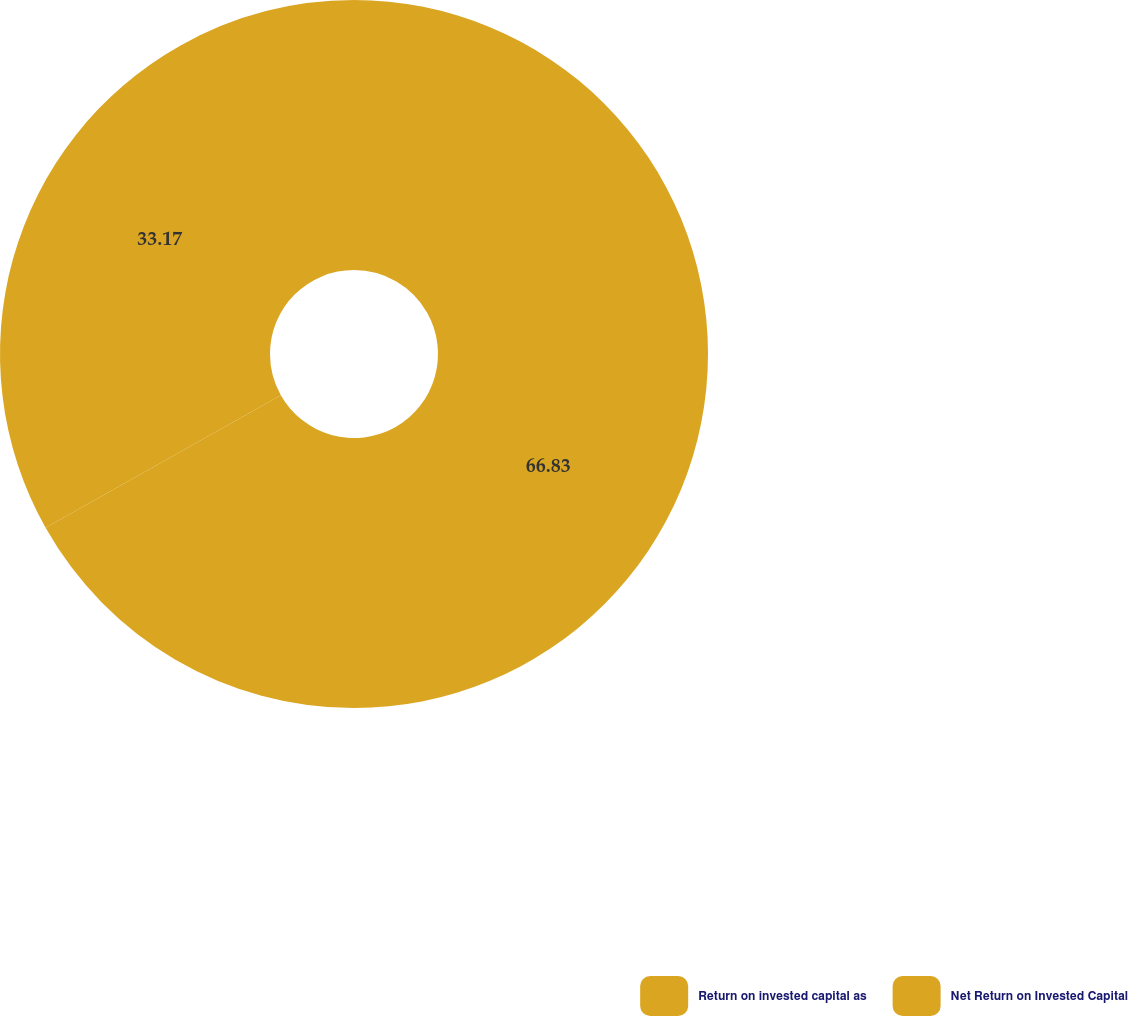Convert chart. <chart><loc_0><loc_0><loc_500><loc_500><pie_chart><fcel>Return on invested capital as<fcel>Net Return on Invested Capital<nl><fcel>66.83%<fcel>33.17%<nl></chart> 